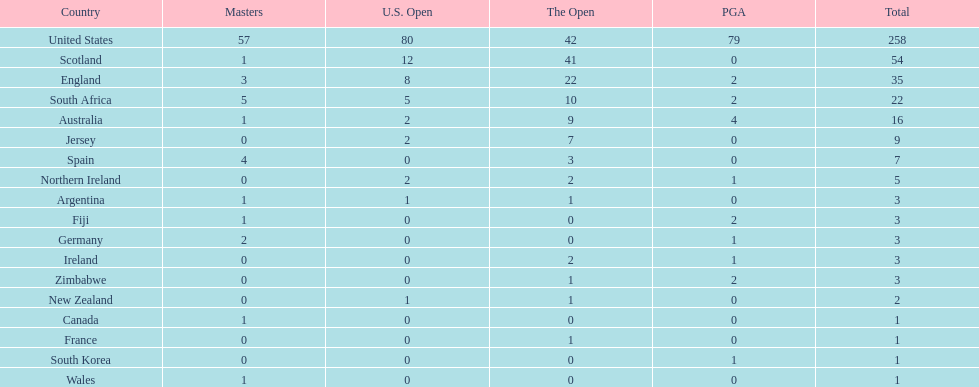How many countries have yielded the same quantity of championship golf players as canada? 3. 